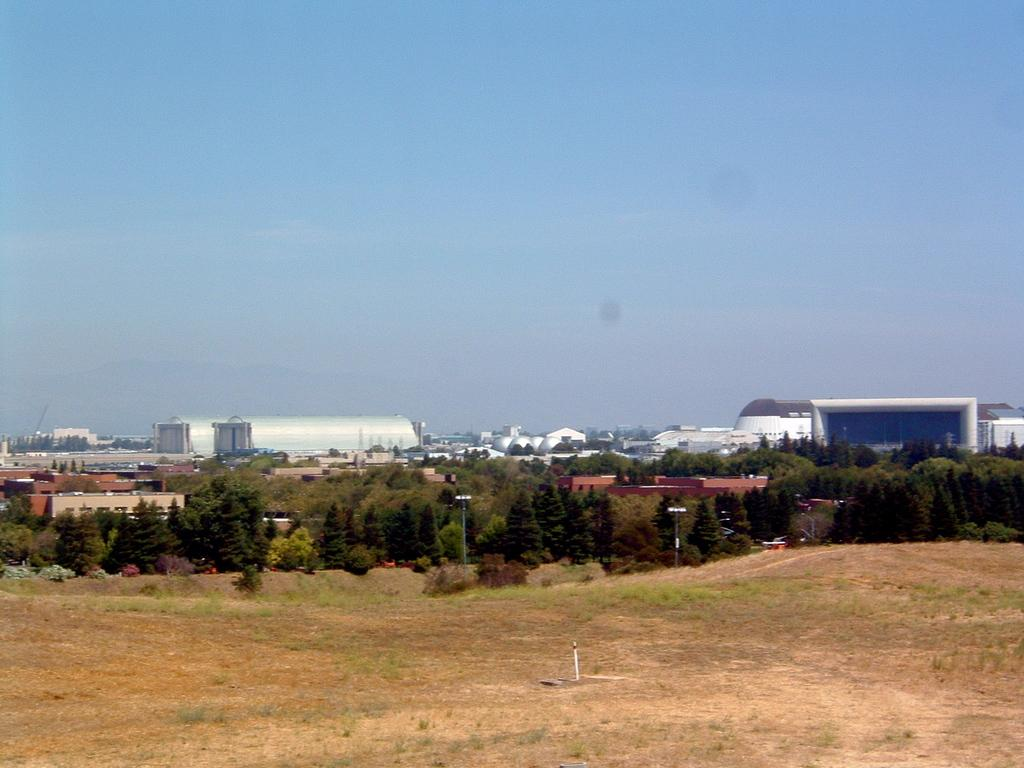What type of vegetation can be seen in the image? There are trees and bushes in the image. What structures are present in the image? There are street poles and street lights in the image. What is visible on the ground in the image? The ground is visible in the image. What type of equipment is present in the image? Factory equipment is present in the image. What part of the natural environment is visible in the image? The sky is visible in the image, and clouds are present in the sky. Can you hear the note being played by the ball in the image? There is no ball or note being played in the image; it features trees, street poles, street lights, bushes, factory equipment, the ground, and the sky with clouds. 